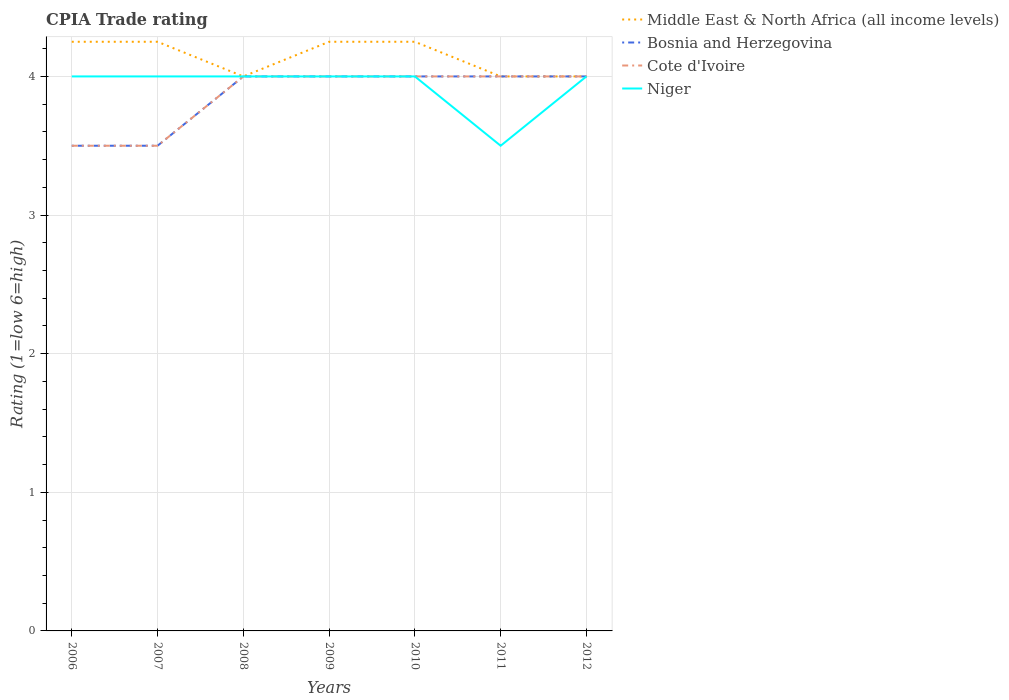Does the line corresponding to Niger intersect with the line corresponding to Cote d'Ivoire?
Your answer should be very brief. Yes. Across all years, what is the maximum CPIA rating in Cote d'Ivoire?
Your answer should be compact. 3.5. In which year was the CPIA rating in Middle East & North Africa (all income levels) maximum?
Provide a succinct answer. 2008. What is the total CPIA rating in Middle East & North Africa (all income levels) in the graph?
Your answer should be very brief. 0. What is the difference between the highest and the second highest CPIA rating in Bosnia and Herzegovina?
Your answer should be very brief. 0.5. What is the difference between the highest and the lowest CPIA rating in Niger?
Your response must be concise. 6. Is the CPIA rating in Cote d'Ivoire strictly greater than the CPIA rating in Bosnia and Herzegovina over the years?
Provide a short and direct response. No. How many lines are there?
Keep it short and to the point. 4. How many years are there in the graph?
Offer a terse response. 7. What is the difference between two consecutive major ticks on the Y-axis?
Keep it short and to the point. 1. Does the graph contain any zero values?
Provide a short and direct response. No. What is the title of the graph?
Give a very brief answer. CPIA Trade rating. What is the Rating (1=low 6=high) in Middle East & North Africa (all income levels) in 2006?
Your response must be concise. 4.25. What is the Rating (1=low 6=high) of Bosnia and Herzegovina in 2006?
Offer a very short reply. 3.5. What is the Rating (1=low 6=high) of Middle East & North Africa (all income levels) in 2007?
Give a very brief answer. 4.25. What is the Rating (1=low 6=high) in Bosnia and Herzegovina in 2007?
Keep it short and to the point. 3.5. What is the Rating (1=low 6=high) in Niger in 2007?
Ensure brevity in your answer.  4. What is the Rating (1=low 6=high) in Middle East & North Africa (all income levels) in 2008?
Ensure brevity in your answer.  4. What is the Rating (1=low 6=high) in Middle East & North Africa (all income levels) in 2009?
Offer a very short reply. 4.25. What is the Rating (1=low 6=high) in Bosnia and Herzegovina in 2009?
Give a very brief answer. 4. What is the Rating (1=low 6=high) of Cote d'Ivoire in 2009?
Your answer should be compact. 4. What is the Rating (1=low 6=high) of Niger in 2009?
Your answer should be compact. 4. What is the Rating (1=low 6=high) in Middle East & North Africa (all income levels) in 2010?
Keep it short and to the point. 4.25. What is the Rating (1=low 6=high) in Bosnia and Herzegovina in 2011?
Provide a short and direct response. 4. What is the Rating (1=low 6=high) of Cote d'Ivoire in 2011?
Offer a terse response. 4. What is the Rating (1=low 6=high) of Niger in 2011?
Give a very brief answer. 3.5. Across all years, what is the maximum Rating (1=low 6=high) in Middle East & North Africa (all income levels)?
Your answer should be very brief. 4.25. Across all years, what is the maximum Rating (1=low 6=high) of Cote d'Ivoire?
Give a very brief answer. 4. Across all years, what is the minimum Rating (1=low 6=high) in Middle East & North Africa (all income levels)?
Offer a terse response. 4. Across all years, what is the minimum Rating (1=low 6=high) of Bosnia and Herzegovina?
Give a very brief answer. 3.5. What is the total Rating (1=low 6=high) in Bosnia and Herzegovina in the graph?
Offer a very short reply. 27. What is the total Rating (1=low 6=high) of Cote d'Ivoire in the graph?
Offer a very short reply. 27. What is the difference between the Rating (1=low 6=high) in Middle East & North Africa (all income levels) in 2006 and that in 2008?
Your answer should be compact. 0.25. What is the difference between the Rating (1=low 6=high) in Cote d'Ivoire in 2006 and that in 2008?
Offer a very short reply. -0.5. What is the difference between the Rating (1=low 6=high) of Niger in 2006 and that in 2008?
Make the answer very short. 0. What is the difference between the Rating (1=low 6=high) in Middle East & North Africa (all income levels) in 2006 and that in 2009?
Provide a succinct answer. 0. What is the difference between the Rating (1=low 6=high) in Cote d'Ivoire in 2006 and that in 2009?
Provide a succinct answer. -0.5. What is the difference between the Rating (1=low 6=high) in Middle East & North Africa (all income levels) in 2006 and that in 2010?
Offer a very short reply. 0. What is the difference between the Rating (1=low 6=high) in Bosnia and Herzegovina in 2006 and that in 2010?
Keep it short and to the point. -0.5. What is the difference between the Rating (1=low 6=high) of Cote d'Ivoire in 2006 and that in 2010?
Your response must be concise. -0.5. What is the difference between the Rating (1=low 6=high) in Niger in 2006 and that in 2010?
Your response must be concise. 0. What is the difference between the Rating (1=low 6=high) of Middle East & North Africa (all income levels) in 2006 and that in 2011?
Keep it short and to the point. 0.25. What is the difference between the Rating (1=low 6=high) of Cote d'Ivoire in 2006 and that in 2011?
Your response must be concise. -0.5. What is the difference between the Rating (1=low 6=high) in Niger in 2006 and that in 2011?
Offer a very short reply. 0.5. What is the difference between the Rating (1=low 6=high) in Cote d'Ivoire in 2006 and that in 2012?
Keep it short and to the point. -0.5. What is the difference between the Rating (1=low 6=high) of Niger in 2006 and that in 2012?
Your response must be concise. 0. What is the difference between the Rating (1=low 6=high) in Middle East & North Africa (all income levels) in 2007 and that in 2008?
Your answer should be very brief. 0.25. What is the difference between the Rating (1=low 6=high) of Cote d'Ivoire in 2007 and that in 2008?
Provide a succinct answer. -0.5. What is the difference between the Rating (1=low 6=high) in Bosnia and Herzegovina in 2007 and that in 2009?
Ensure brevity in your answer.  -0.5. What is the difference between the Rating (1=low 6=high) of Cote d'Ivoire in 2007 and that in 2009?
Give a very brief answer. -0.5. What is the difference between the Rating (1=low 6=high) of Niger in 2007 and that in 2009?
Your response must be concise. 0. What is the difference between the Rating (1=low 6=high) of Middle East & North Africa (all income levels) in 2007 and that in 2010?
Provide a short and direct response. 0. What is the difference between the Rating (1=low 6=high) of Bosnia and Herzegovina in 2007 and that in 2010?
Provide a short and direct response. -0.5. What is the difference between the Rating (1=low 6=high) of Niger in 2007 and that in 2010?
Your response must be concise. 0. What is the difference between the Rating (1=low 6=high) in Cote d'Ivoire in 2007 and that in 2011?
Give a very brief answer. -0.5. What is the difference between the Rating (1=low 6=high) of Middle East & North Africa (all income levels) in 2007 and that in 2012?
Your response must be concise. 0.25. What is the difference between the Rating (1=low 6=high) of Middle East & North Africa (all income levels) in 2008 and that in 2009?
Offer a terse response. -0.25. What is the difference between the Rating (1=low 6=high) in Bosnia and Herzegovina in 2008 and that in 2009?
Make the answer very short. 0. What is the difference between the Rating (1=low 6=high) in Middle East & North Africa (all income levels) in 2008 and that in 2010?
Your answer should be very brief. -0.25. What is the difference between the Rating (1=low 6=high) in Bosnia and Herzegovina in 2008 and that in 2011?
Provide a succinct answer. 0. What is the difference between the Rating (1=low 6=high) of Cote d'Ivoire in 2008 and that in 2011?
Provide a short and direct response. 0. What is the difference between the Rating (1=low 6=high) in Middle East & North Africa (all income levels) in 2008 and that in 2012?
Ensure brevity in your answer.  0. What is the difference between the Rating (1=low 6=high) of Bosnia and Herzegovina in 2008 and that in 2012?
Give a very brief answer. 0. What is the difference between the Rating (1=low 6=high) of Cote d'Ivoire in 2009 and that in 2010?
Your answer should be very brief. 0. What is the difference between the Rating (1=low 6=high) of Middle East & North Africa (all income levels) in 2009 and that in 2011?
Give a very brief answer. 0.25. What is the difference between the Rating (1=low 6=high) of Bosnia and Herzegovina in 2009 and that in 2011?
Offer a very short reply. 0. What is the difference between the Rating (1=low 6=high) in Cote d'Ivoire in 2009 and that in 2011?
Provide a succinct answer. 0. What is the difference between the Rating (1=low 6=high) in Middle East & North Africa (all income levels) in 2009 and that in 2012?
Make the answer very short. 0.25. What is the difference between the Rating (1=low 6=high) in Cote d'Ivoire in 2009 and that in 2012?
Provide a succinct answer. 0. What is the difference between the Rating (1=low 6=high) of Niger in 2009 and that in 2012?
Ensure brevity in your answer.  0. What is the difference between the Rating (1=low 6=high) of Middle East & North Africa (all income levels) in 2010 and that in 2011?
Offer a terse response. 0.25. What is the difference between the Rating (1=low 6=high) of Bosnia and Herzegovina in 2010 and that in 2011?
Your answer should be very brief. 0. What is the difference between the Rating (1=low 6=high) of Cote d'Ivoire in 2010 and that in 2011?
Provide a succinct answer. 0. What is the difference between the Rating (1=low 6=high) in Niger in 2010 and that in 2011?
Your answer should be compact. 0.5. What is the difference between the Rating (1=low 6=high) in Bosnia and Herzegovina in 2010 and that in 2012?
Your response must be concise. 0. What is the difference between the Rating (1=low 6=high) in Cote d'Ivoire in 2010 and that in 2012?
Your answer should be compact. 0. What is the difference between the Rating (1=low 6=high) in Bosnia and Herzegovina in 2011 and that in 2012?
Keep it short and to the point. 0. What is the difference between the Rating (1=low 6=high) of Cote d'Ivoire in 2011 and that in 2012?
Offer a very short reply. 0. What is the difference between the Rating (1=low 6=high) of Middle East & North Africa (all income levels) in 2006 and the Rating (1=low 6=high) of Cote d'Ivoire in 2007?
Offer a terse response. 0.75. What is the difference between the Rating (1=low 6=high) of Bosnia and Herzegovina in 2006 and the Rating (1=low 6=high) of Cote d'Ivoire in 2007?
Give a very brief answer. 0. What is the difference between the Rating (1=low 6=high) in Bosnia and Herzegovina in 2006 and the Rating (1=low 6=high) in Niger in 2007?
Your answer should be compact. -0.5. What is the difference between the Rating (1=low 6=high) in Cote d'Ivoire in 2006 and the Rating (1=low 6=high) in Niger in 2007?
Your answer should be compact. -0.5. What is the difference between the Rating (1=low 6=high) in Bosnia and Herzegovina in 2006 and the Rating (1=low 6=high) in Niger in 2008?
Make the answer very short. -0.5. What is the difference between the Rating (1=low 6=high) of Cote d'Ivoire in 2006 and the Rating (1=low 6=high) of Niger in 2008?
Keep it short and to the point. -0.5. What is the difference between the Rating (1=low 6=high) of Middle East & North Africa (all income levels) in 2006 and the Rating (1=low 6=high) of Cote d'Ivoire in 2009?
Offer a very short reply. 0.25. What is the difference between the Rating (1=low 6=high) in Middle East & North Africa (all income levels) in 2006 and the Rating (1=low 6=high) in Niger in 2009?
Your answer should be compact. 0.25. What is the difference between the Rating (1=low 6=high) in Bosnia and Herzegovina in 2006 and the Rating (1=low 6=high) in Niger in 2009?
Offer a terse response. -0.5. What is the difference between the Rating (1=low 6=high) in Cote d'Ivoire in 2006 and the Rating (1=low 6=high) in Niger in 2009?
Give a very brief answer. -0.5. What is the difference between the Rating (1=low 6=high) in Middle East & North Africa (all income levels) in 2006 and the Rating (1=low 6=high) in Bosnia and Herzegovina in 2010?
Your answer should be very brief. 0.25. What is the difference between the Rating (1=low 6=high) of Middle East & North Africa (all income levels) in 2006 and the Rating (1=low 6=high) of Cote d'Ivoire in 2010?
Provide a short and direct response. 0.25. What is the difference between the Rating (1=low 6=high) of Bosnia and Herzegovina in 2006 and the Rating (1=low 6=high) of Niger in 2010?
Offer a terse response. -0.5. What is the difference between the Rating (1=low 6=high) of Middle East & North Africa (all income levels) in 2006 and the Rating (1=low 6=high) of Bosnia and Herzegovina in 2011?
Your response must be concise. 0.25. What is the difference between the Rating (1=low 6=high) of Middle East & North Africa (all income levels) in 2006 and the Rating (1=low 6=high) of Niger in 2011?
Provide a short and direct response. 0.75. What is the difference between the Rating (1=low 6=high) in Bosnia and Herzegovina in 2006 and the Rating (1=low 6=high) in Niger in 2011?
Offer a terse response. 0. What is the difference between the Rating (1=low 6=high) of Cote d'Ivoire in 2006 and the Rating (1=low 6=high) of Niger in 2011?
Your response must be concise. 0. What is the difference between the Rating (1=low 6=high) of Middle East & North Africa (all income levels) in 2006 and the Rating (1=low 6=high) of Cote d'Ivoire in 2012?
Offer a very short reply. 0.25. What is the difference between the Rating (1=low 6=high) in Cote d'Ivoire in 2006 and the Rating (1=low 6=high) in Niger in 2012?
Offer a terse response. -0.5. What is the difference between the Rating (1=low 6=high) in Middle East & North Africa (all income levels) in 2007 and the Rating (1=low 6=high) in Cote d'Ivoire in 2008?
Provide a short and direct response. 0.25. What is the difference between the Rating (1=low 6=high) in Bosnia and Herzegovina in 2007 and the Rating (1=low 6=high) in Niger in 2008?
Ensure brevity in your answer.  -0.5. What is the difference between the Rating (1=low 6=high) in Middle East & North Africa (all income levels) in 2007 and the Rating (1=low 6=high) in Bosnia and Herzegovina in 2009?
Your response must be concise. 0.25. What is the difference between the Rating (1=low 6=high) of Middle East & North Africa (all income levels) in 2007 and the Rating (1=low 6=high) of Cote d'Ivoire in 2009?
Keep it short and to the point. 0.25. What is the difference between the Rating (1=low 6=high) of Bosnia and Herzegovina in 2007 and the Rating (1=low 6=high) of Niger in 2009?
Your answer should be very brief. -0.5. What is the difference between the Rating (1=low 6=high) of Middle East & North Africa (all income levels) in 2007 and the Rating (1=low 6=high) of Bosnia and Herzegovina in 2010?
Provide a short and direct response. 0.25. What is the difference between the Rating (1=low 6=high) in Middle East & North Africa (all income levels) in 2007 and the Rating (1=low 6=high) in Niger in 2010?
Offer a very short reply. 0.25. What is the difference between the Rating (1=low 6=high) in Bosnia and Herzegovina in 2007 and the Rating (1=low 6=high) in Niger in 2010?
Your answer should be very brief. -0.5. What is the difference between the Rating (1=low 6=high) in Cote d'Ivoire in 2007 and the Rating (1=low 6=high) in Niger in 2010?
Ensure brevity in your answer.  -0.5. What is the difference between the Rating (1=low 6=high) in Middle East & North Africa (all income levels) in 2007 and the Rating (1=low 6=high) in Cote d'Ivoire in 2011?
Provide a succinct answer. 0.25. What is the difference between the Rating (1=low 6=high) of Bosnia and Herzegovina in 2007 and the Rating (1=low 6=high) of Cote d'Ivoire in 2012?
Make the answer very short. -0.5. What is the difference between the Rating (1=low 6=high) in Bosnia and Herzegovina in 2007 and the Rating (1=low 6=high) in Niger in 2012?
Your answer should be very brief. -0.5. What is the difference between the Rating (1=low 6=high) in Cote d'Ivoire in 2007 and the Rating (1=low 6=high) in Niger in 2012?
Offer a very short reply. -0.5. What is the difference between the Rating (1=low 6=high) of Middle East & North Africa (all income levels) in 2008 and the Rating (1=low 6=high) of Niger in 2009?
Ensure brevity in your answer.  0. What is the difference between the Rating (1=low 6=high) in Bosnia and Herzegovina in 2008 and the Rating (1=low 6=high) in Cote d'Ivoire in 2009?
Keep it short and to the point. 0. What is the difference between the Rating (1=low 6=high) of Bosnia and Herzegovina in 2008 and the Rating (1=low 6=high) of Niger in 2009?
Keep it short and to the point. 0. What is the difference between the Rating (1=low 6=high) of Cote d'Ivoire in 2008 and the Rating (1=low 6=high) of Niger in 2009?
Your answer should be compact. 0. What is the difference between the Rating (1=low 6=high) of Bosnia and Herzegovina in 2008 and the Rating (1=low 6=high) of Niger in 2010?
Provide a short and direct response. 0. What is the difference between the Rating (1=low 6=high) in Middle East & North Africa (all income levels) in 2008 and the Rating (1=low 6=high) in Bosnia and Herzegovina in 2011?
Provide a short and direct response. 0. What is the difference between the Rating (1=low 6=high) of Cote d'Ivoire in 2008 and the Rating (1=low 6=high) of Niger in 2011?
Ensure brevity in your answer.  0.5. What is the difference between the Rating (1=low 6=high) of Middle East & North Africa (all income levels) in 2008 and the Rating (1=low 6=high) of Cote d'Ivoire in 2012?
Provide a short and direct response. 0. What is the difference between the Rating (1=low 6=high) of Bosnia and Herzegovina in 2008 and the Rating (1=low 6=high) of Cote d'Ivoire in 2012?
Provide a short and direct response. 0. What is the difference between the Rating (1=low 6=high) of Middle East & North Africa (all income levels) in 2009 and the Rating (1=low 6=high) of Bosnia and Herzegovina in 2010?
Offer a very short reply. 0.25. What is the difference between the Rating (1=low 6=high) in Middle East & North Africa (all income levels) in 2009 and the Rating (1=low 6=high) in Cote d'Ivoire in 2010?
Offer a very short reply. 0.25. What is the difference between the Rating (1=low 6=high) of Middle East & North Africa (all income levels) in 2009 and the Rating (1=low 6=high) of Niger in 2010?
Your answer should be compact. 0.25. What is the difference between the Rating (1=low 6=high) of Bosnia and Herzegovina in 2009 and the Rating (1=low 6=high) of Cote d'Ivoire in 2010?
Your answer should be very brief. 0. What is the difference between the Rating (1=low 6=high) of Bosnia and Herzegovina in 2009 and the Rating (1=low 6=high) of Niger in 2010?
Give a very brief answer. 0. What is the difference between the Rating (1=low 6=high) in Middle East & North Africa (all income levels) in 2009 and the Rating (1=low 6=high) in Bosnia and Herzegovina in 2011?
Ensure brevity in your answer.  0.25. What is the difference between the Rating (1=low 6=high) in Middle East & North Africa (all income levels) in 2009 and the Rating (1=low 6=high) in Cote d'Ivoire in 2011?
Your answer should be compact. 0.25. What is the difference between the Rating (1=low 6=high) of Middle East & North Africa (all income levels) in 2009 and the Rating (1=low 6=high) of Niger in 2011?
Offer a terse response. 0.75. What is the difference between the Rating (1=low 6=high) in Bosnia and Herzegovina in 2009 and the Rating (1=low 6=high) in Cote d'Ivoire in 2011?
Your answer should be compact. 0. What is the difference between the Rating (1=low 6=high) in Cote d'Ivoire in 2009 and the Rating (1=low 6=high) in Niger in 2011?
Make the answer very short. 0.5. What is the difference between the Rating (1=low 6=high) of Middle East & North Africa (all income levels) in 2009 and the Rating (1=low 6=high) of Bosnia and Herzegovina in 2012?
Offer a very short reply. 0.25. What is the difference between the Rating (1=low 6=high) of Middle East & North Africa (all income levels) in 2009 and the Rating (1=low 6=high) of Niger in 2012?
Offer a very short reply. 0.25. What is the difference between the Rating (1=low 6=high) of Bosnia and Herzegovina in 2009 and the Rating (1=low 6=high) of Cote d'Ivoire in 2012?
Your answer should be very brief. 0. What is the difference between the Rating (1=low 6=high) in Middle East & North Africa (all income levels) in 2010 and the Rating (1=low 6=high) in Niger in 2011?
Your answer should be compact. 0.75. What is the difference between the Rating (1=low 6=high) of Middle East & North Africa (all income levels) in 2010 and the Rating (1=low 6=high) of Niger in 2012?
Keep it short and to the point. 0.25. What is the difference between the Rating (1=low 6=high) of Bosnia and Herzegovina in 2010 and the Rating (1=low 6=high) of Niger in 2012?
Offer a terse response. 0. What is the difference between the Rating (1=low 6=high) of Middle East & North Africa (all income levels) in 2011 and the Rating (1=low 6=high) of Cote d'Ivoire in 2012?
Provide a short and direct response. 0. What is the difference between the Rating (1=low 6=high) in Cote d'Ivoire in 2011 and the Rating (1=low 6=high) in Niger in 2012?
Your response must be concise. 0. What is the average Rating (1=low 6=high) of Middle East & North Africa (all income levels) per year?
Your response must be concise. 4.14. What is the average Rating (1=low 6=high) of Bosnia and Herzegovina per year?
Make the answer very short. 3.86. What is the average Rating (1=low 6=high) of Cote d'Ivoire per year?
Ensure brevity in your answer.  3.86. What is the average Rating (1=low 6=high) of Niger per year?
Your response must be concise. 3.93. In the year 2006, what is the difference between the Rating (1=low 6=high) of Middle East & North Africa (all income levels) and Rating (1=low 6=high) of Bosnia and Herzegovina?
Offer a very short reply. 0.75. In the year 2006, what is the difference between the Rating (1=low 6=high) of Bosnia and Herzegovina and Rating (1=low 6=high) of Cote d'Ivoire?
Ensure brevity in your answer.  0. In the year 2007, what is the difference between the Rating (1=low 6=high) in Middle East & North Africa (all income levels) and Rating (1=low 6=high) in Bosnia and Herzegovina?
Give a very brief answer. 0.75. In the year 2008, what is the difference between the Rating (1=low 6=high) of Middle East & North Africa (all income levels) and Rating (1=low 6=high) of Niger?
Provide a short and direct response. 0. In the year 2009, what is the difference between the Rating (1=low 6=high) in Bosnia and Herzegovina and Rating (1=low 6=high) in Cote d'Ivoire?
Make the answer very short. 0. In the year 2009, what is the difference between the Rating (1=low 6=high) in Bosnia and Herzegovina and Rating (1=low 6=high) in Niger?
Offer a terse response. 0. In the year 2009, what is the difference between the Rating (1=low 6=high) in Cote d'Ivoire and Rating (1=low 6=high) in Niger?
Ensure brevity in your answer.  0. In the year 2010, what is the difference between the Rating (1=low 6=high) of Middle East & North Africa (all income levels) and Rating (1=low 6=high) of Bosnia and Herzegovina?
Provide a succinct answer. 0.25. In the year 2010, what is the difference between the Rating (1=low 6=high) of Middle East & North Africa (all income levels) and Rating (1=low 6=high) of Cote d'Ivoire?
Provide a succinct answer. 0.25. In the year 2010, what is the difference between the Rating (1=low 6=high) in Bosnia and Herzegovina and Rating (1=low 6=high) in Cote d'Ivoire?
Your answer should be very brief. 0. In the year 2010, what is the difference between the Rating (1=low 6=high) of Cote d'Ivoire and Rating (1=low 6=high) of Niger?
Ensure brevity in your answer.  0. In the year 2011, what is the difference between the Rating (1=low 6=high) of Middle East & North Africa (all income levels) and Rating (1=low 6=high) of Bosnia and Herzegovina?
Give a very brief answer. 0. In the year 2011, what is the difference between the Rating (1=low 6=high) of Middle East & North Africa (all income levels) and Rating (1=low 6=high) of Cote d'Ivoire?
Offer a terse response. 0. In the year 2011, what is the difference between the Rating (1=low 6=high) of Middle East & North Africa (all income levels) and Rating (1=low 6=high) of Niger?
Your answer should be compact. 0.5. In the year 2011, what is the difference between the Rating (1=low 6=high) in Bosnia and Herzegovina and Rating (1=low 6=high) in Niger?
Make the answer very short. 0.5. In the year 2012, what is the difference between the Rating (1=low 6=high) in Middle East & North Africa (all income levels) and Rating (1=low 6=high) in Bosnia and Herzegovina?
Offer a terse response. 0. In the year 2012, what is the difference between the Rating (1=low 6=high) in Middle East & North Africa (all income levels) and Rating (1=low 6=high) in Niger?
Keep it short and to the point. 0. In the year 2012, what is the difference between the Rating (1=low 6=high) in Bosnia and Herzegovina and Rating (1=low 6=high) in Cote d'Ivoire?
Offer a very short reply. 0. In the year 2012, what is the difference between the Rating (1=low 6=high) of Bosnia and Herzegovina and Rating (1=low 6=high) of Niger?
Your response must be concise. 0. In the year 2012, what is the difference between the Rating (1=low 6=high) in Cote d'Ivoire and Rating (1=low 6=high) in Niger?
Give a very brief answer. 0. What is the ratio of the Rating (1=low 6=high) of Bosnia and Herzegovina in 2006 to that in 2007?
Your response must be concise. 1. What is the ratio of the Rating (1=low 6=high) of Niger in 2006 to that in 2007?
Offer a very short reply. 1. What is the ratio of the Rating (1=low 6=high) in Bosnia and Herzegovina in 2006 to that in 2009?
Your answer should be compact. 0.88. What is the ratio of the Rating (1=low 6=high) of Niger in 2006 to that in 2009?
Keep it short and to the point. 1. What is the ratio of the Rating (1=low 6=high) of Middle East & North Africa (all income levels) in 2006 to that in 2010?
Your answer should be very brief. 1. What is the ratio of the Rating (1=low 6=high) in Cote d'Ivoire in 2006 to that in 2010?
Provide a succinct answer. 0.88. What is the ratio of the Rating (1=low 6=high) of Bosnia and Herzegovina in 2006 to that in 2011?
Offer a very short reply. 0.88. What is the ratio of the Rating (1=low 6=high) in Cote d'Ivoire in 2006 to that in 2011?
Make the answer very short. 0.88. What is the ratio of the Rating (1=low 6=high) in Middle East & North Africa (all income levels) in 2006 to that in 2012?
Provide a succinct answer. 1.06. What is the ratio of the Rating (1=low 6=high) in Cote d'Ivoire in 2006 to that in 2012?
Provide a succinct answer. 0.88. What is the ratio of the Rating (1=low 6=high) of Middle East & North Africa (all income levels) in 2007 to that in 2008?
Ensure brevity in your answer.  1.06. What is the ratio of the Rating (1=low 6=high) of Cote d'Ivoire in 2007 to that in 2008?
Offer a terse response. 0.88. What is the ratio of the Rating (1=low 6=high) of Niger in 2007 to that in 2008?
Your answer should be very brief. 1. What is the ratio of the Rating (1=low 6=high) of Middle East & North Africa (all income levels) in 2007 to that in 2009?
Give a very brief answer. 1. What is the ratio of the Rating (1=low 6=high) of Cote d'Ivoire in 2007 to that in 2009?
Ensure brevity in your answer.  0.88. What is the ratio of the Rating (1=low 6=high) of Niger in 2007 to that in 2009?
Make the answer very short. 1. What is the ratio of the Rating (1=low 6=high) in Middle East & North Africa (all income levels) in 2007 to that in 2010?
Your answer should be very brief. 1. What is the ratio of the Rating (1=low 6=high) of Cote d'Ivoire in 2007 to that in 2010?
Your answer should be very brief. 0.88. What is the ratio of the Rating (1=low 6=high) in Niger in 2007 to that in 2010?
Ensure brevity in your answer.  1. What is the ratio of the Rating (1=low 6=high) of Middle East & North Africa (all income levels) in 2007 to that in 2011?
Keep it short and to the point. 1.06. What is the ratio of the Rating (1=low 6=high) in Cote d'Ivoire in 2007 to that in 2011?
Your answer should be very brief. 0.88. What is the ratio of the Rating (1=low 6=high) in Bosnia and Herzegovina in 2007 to that in 2012?
Keep it short and to the point. 0.88. What is the ratio of the Rating (1=low 6=high) in Cote d'Ivoire in 2008 to that in 2009?
Ensure brevity in your answer.  1. What is the ratio of the Rating (1=low 6=high) in Middle East & North Africa (all income levels) in 2008 to that in 2010?
Offer a very short reply. 0.94. What is the ratio of the Rating (1=low 6=high) in Bosnia and Herzegovina in 2008 to that in 2010?
Offer a terse response. 1. What is the ratio of the Rating (1=low 6=high) in Niger in 2008 to that in 2010?
Offer a terse response. 1. What is the ratio of the Rating (1=low 6=high) of Cote d'Ivoire in 2008 to that in 2011?
Offer a very short reply. 1. What is the ratio of the Rating (1=low 6=high) in Niger in 2008 to that in 2012?
Keep it short and to the point. 1. What is the ratio of the Rating (1=low 6=high) of Niger in 2009 to that in 2010?
Your answer should be very brief. 1. What is the ratio of the Rating (1=low 6=high) of Middle East & North Africa (all income levels) in 2009 to that in 2011?
Your response must be concise. 1.06. What is the ratio of the Rating (1=low 6=high) of Niger in 2009 to that in 2011?
Your answer should be compact. 1.14. What is the ratio of the Rating (1=low 6=high) in Niger in 2010 to that in 2012?
Keep it short and to the point. 1. What is the ratio of the Rating (1=low 6=high) in Middle East & North Africa (all income levels) in 2011 to that in 2012?
Offer a very short reply. 1. What is the ratio of the Rating (1=low 6=high) in Cote d'Ivoire in 2011 to that in 2012?
Keep it short and to the point. 1. What is the ratio of the Rating (1=low 6=high) of Niger in 2011 to that in 2012?
Provide a short and direct response. 0.88. What is the difference between the highest and the second highest Rating (1=low 6=high) in Bosnia and Herzegovina?
Give a very brief answer. 0. What is the difference between the highest and the second highest Rating (1=low 6=high) of Cote d'Ivoire?
Provide a succinct answer. 0. 